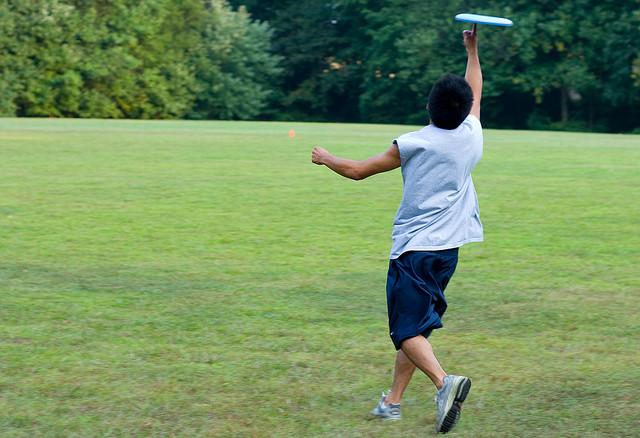Is this the summertime?
Give a very brief answer. Yes. What color are his shoes?
Answer briefly. White. What color is the frisbee?
Quick response, please. Blue. What is the boy catching?
Answer briefly. Frisbee. What game are they playing?
Write a very short answer. Frisbee. 